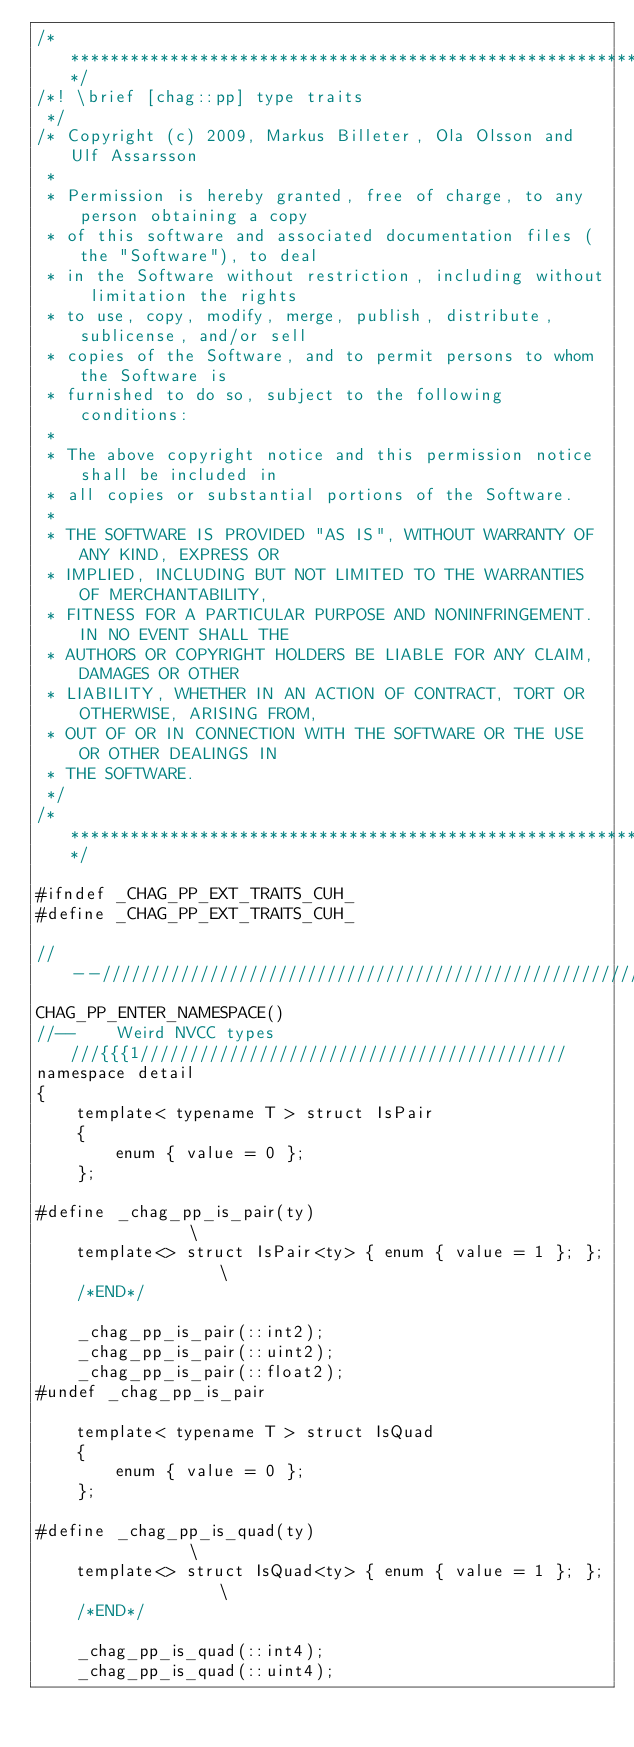Convert code to text. <code><loc_0><loc_0><loc_500><loc_500><_Cuda_>/****************************************************************************/
/*!	\brief [chag::pp] type traits
 */
/* Copyright (c) 2009, Markus Billeter, Ola Olsson and Ulf Assarsson
 * 
 * Permission is hereby granted, free of charge, to any person obtaining a copy
 * of this software and associated documentation files (the "Software"), to deal
 * in the Software without restriction, including without limitation the rights
 * to use, copy, modify, merge, publish, distribute, sublicense, and/or sell
 * copies of the Software, and to permit persons to whom the Software is
 * furnished to do so, subject to the following conditions:
 * 
 * The above copyright notice and this permission notice shall be included in
 * all copies or substantial portions of the Software.
 * 
 * THE SOFTWARE IS PROVIDED "AS IS", WITHOUT WARRANTY OF ANY KIND, EXPRESS OR
 * IMPLIED, INCLUDING BUT NOT LIMITED TO THE WARRANTIES OF MERCHANTABILITY,
 * FITNESS FOR A PARTICULAR PURPOSE AND NONINFRINGEMENT. IN NO EVENT SHALL THE
 * AUTHORS OR COPYRIGHT HOLDERS BE LIABLE FOR ANY CLAIM, DAMAGES OR OTHER
 * LIABILITY, WHETHER IN AN ACTION OF CONTRACT, TORT OR OTHERWISE, ARISING FROM,
 * OUT OF OR IN CONNECTION WITH THE SOFTWARE OR THE USE OR OTHER DEALINGS IN
 * THE SOFTWARE.
 */
/****************************************************************************/

#ifndef _CHAG_PP_EXT_TRAITS_CUH_
#define _CHAG_PP_EXT_TRAITS_CUH_

//--//////////////////////////////////////////////////////////////////////////
CHAG_PP_ENTER_NAMESPACE()
//--	Weird NVCC types	///{{{1///////////////////////////////////////////
namespace detail
{
	template< typename T > struct IsPair
	{
		enum { value = 0 };
	};

#define _chag_pp_is_pair(ty)										\
	template<> struct IsPair<ty> { enum { value = 1 }; };			\
	/*END*/

	_chag_pp_is_pair(::int2);
	_chag_pp_is_pair(::uint2);
	_chag_pp_is_pair(::float2);
#undef _chag_pp_is_pair

	template< typename T > struct IsQuad
	{
		enum { value = 0 };
	};

#define _chag_pp_is_quad(ty)										\
	template<> struct IsQuad<ty> { enum { value = 1 }; };			\
	/*END*/

	_chag_pp_is_quad(::int4);
	_chag_pp_is_quad(::uint4);</code> 